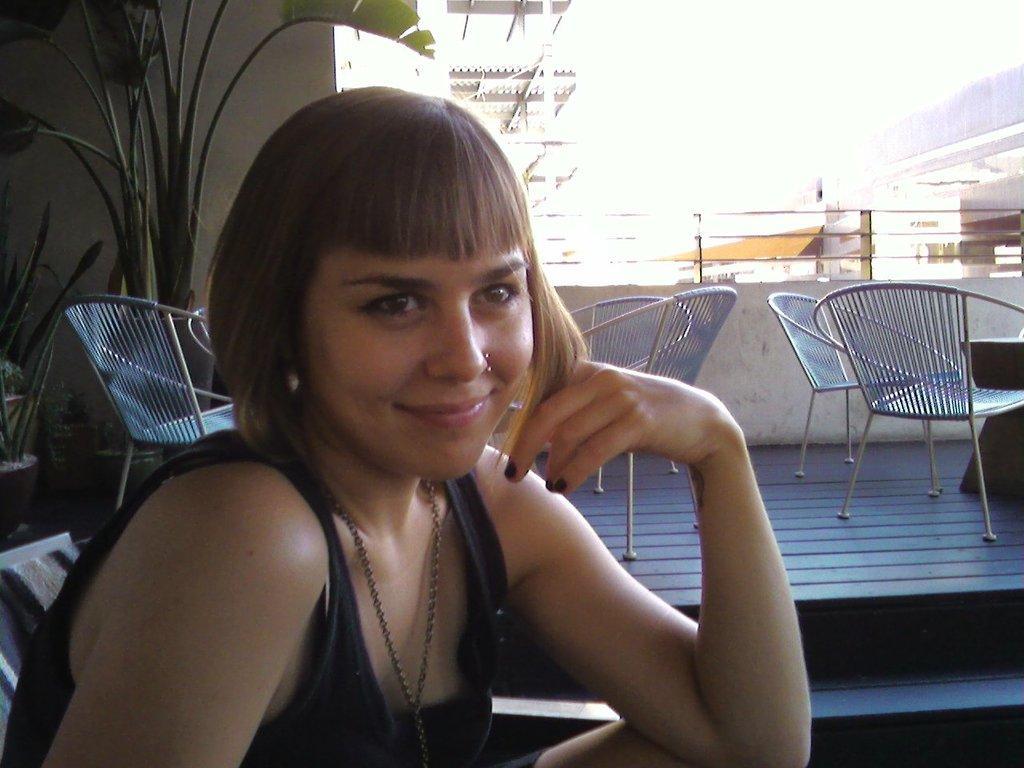Describe this image in one or two sentences. In this image in front there is a person wearing a smile on her face. Behind her there are chairs. There are flower pots. There is a metal fence. There is a wall. In the background of the image there are buildings. 